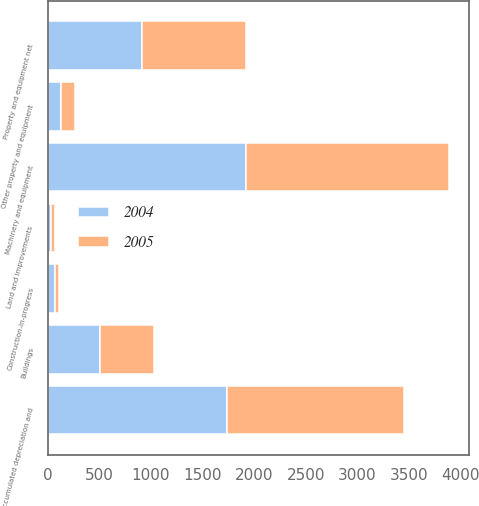<chart> <loc_0><loc_0><loc_500><loc_500><stacked_bar_chart><ecel><fcel>Land and improvements<fcel>Buildings<fcel>Machinery and equipment<fcel>Other property and equipment<fcel>Construction-in-progress<fcel>Accumulated depreciation and<fcel>Property and equipment net<nl><fcel>2004<fcel>32.8<fcel>508.6<fcel>1917.7<fcel>126.9<fcel>66.7<fcel>1741.5<fcel>911.2<nl><fcel>2005<fcel>35.5<fcel>524.9<fcel>1969.6<fcel>137<fcel>46.5<fcel>1704.9<fcel>1008.6<nl></chart> 